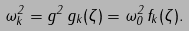<formula> <loc_0><loc_0><loc_500><loc_500>\omega _ { k } ^ { 2 } = g ^ { 2 } \, g _ { k } ( \zeta ) = \omega _ { 0 } ^ { 2 } \, f _ { k } ( \zeta ) .</formula> 